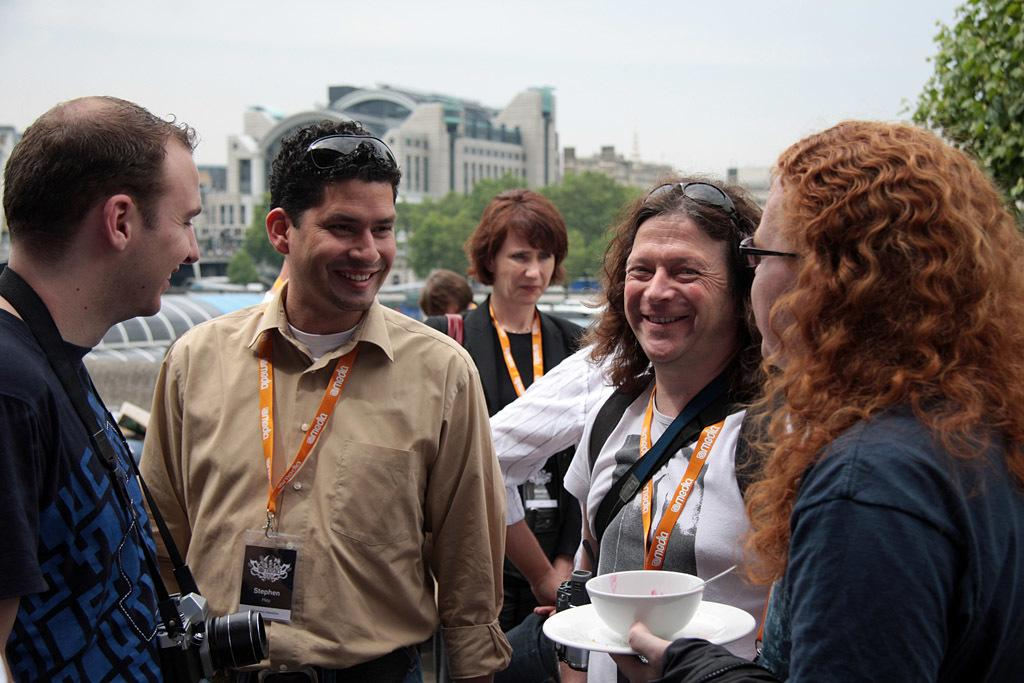What is the main subject of the image? There are people in the center of the image. What can be seen in the background of the image? There are buildings and trees in the background of the image. What type of crayon is being used by the people in the image? There is no crayon present in the image; the people are not depicted using any drawing or writing utensils. 